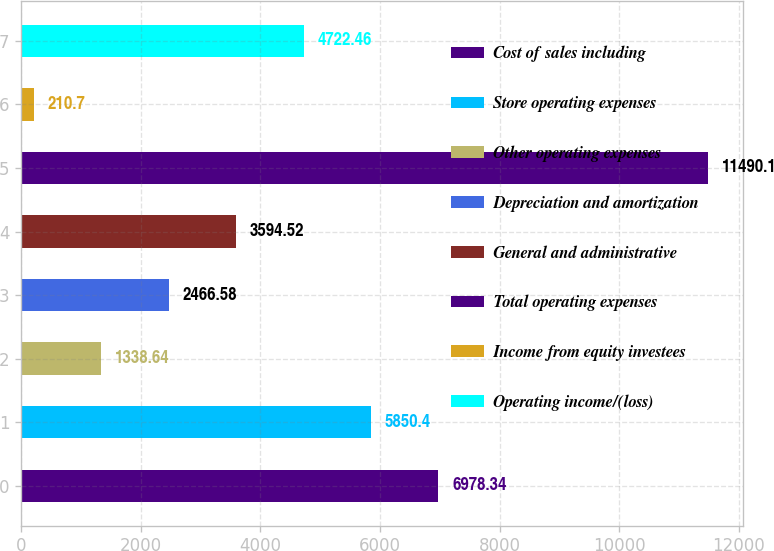Convert chart. <chart><loc_0><loc_0><loc_500><loc_500><bar_chart><fcel>Cost of sales including<fcel>Store operating expenses<fcel>Other operating expenses<fcel>Depreciation and amortization<fcel>General and administrative<fcel>Total operating expenses<fcel>Income from equity investees<fcel>Operating income/(loss)<nl><fcel>6978.34<fcel>5850.4<fcel>1338.64<fcel>2466.58<fcel>3594.52<fcel>11490.1<fcel>210.7<fcel>4722.46<nl></chart> 